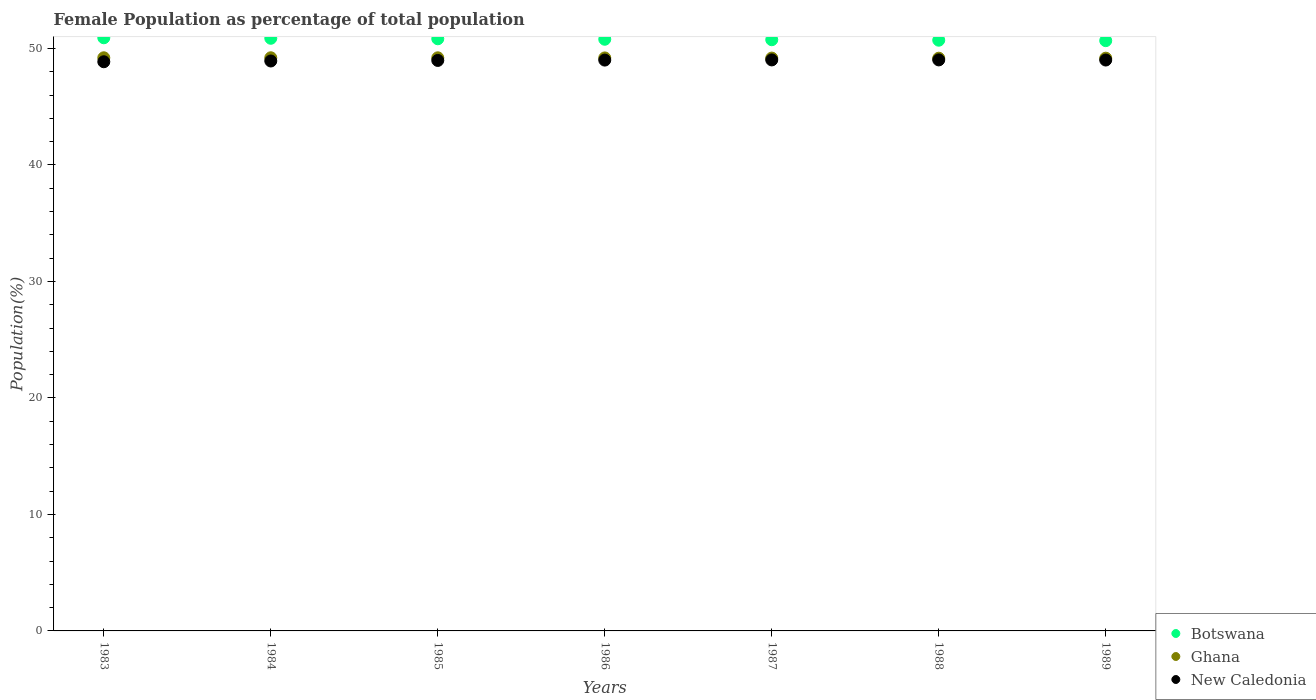What is the female population in in Botswana in 1984?
Ensure brevity in your answer.  50.87. Across all years, what is the maximum female population in in Botswana?
Ensure brevity in your answer.  50.91. Across all years, what is the minimum female population in in Ghana?
Ensure brevity in your answer.  49.16. In which year was the female population in in Botswana maximum?
Offer a very short reply. 1983. What is the total female population in in New Caledonia in the graph?
Give a very brief answer. 342.78. What is the difference between the female population in in New Caledonia in 1984 and that in 1989?
Keep it short and to the point. -0.08. What is the difference between the female population in in Ghana in 1983 and the female population in in Botswana in 1987?
Make the answer very short. -1.55. What is the average female population in in New Caledonia per year?
Your response must be concise. 48.97. In the year 1989, what is the difference between the female population in in Botswana and female population in in Ghana?
Provide a short and direct response. 1.51. What is the ratio of the female population in in New Caledonia in 1985 to that in 1986?
Offer a very short reply. 1. Is the difference between the female population in in Botswana in 1983 and 1988 greater than the difference between the female population in in Ghana in 1983 and 1988?
Your response must be concise. Yes. What is the difference between the highest and the second highest female population in in Botswana?
Your answer should be compact. 0.04. What is the difference between the highest and the lowest female population in in Botswana?
Provide a short and direct response. 0.25. In how many years, is the female population in in Botswana greater than the average female population in in Botswana taken over all years?
Offer a terse response. 3. Is it the case that in every year, the sum of the female population in in New Caledonia and female population in in Ghana  is greater than the female population in in Botswana?
Your answer should be compact. Yes. Is the female population in in Botswana strictly greater than the female population in in Ghana over the years?
Your response must be concise. Yes. Is the female population in in Botswana strictly less than the female population in in New Caledonia over the years?
Keep it short and to the point. No. How many years are there in the graph?
Give a very brief answer. 7. What is the difference between two consecutive major ticks on the Y-axis?
Your response must be concise. 10. Does the graph contain grids?
Offer a very short reply. No. How are the legend labels stacked?
Offer a very short reply. Vertical. What is the title of the graph?
Your answer should be compact. Female Population as percentage of total population. What is the label or title of the Y-axis?
Your response must be concise. Population(%). What is the Population(%) in Botswana in 1983?
Ensure brevity in your answer.  50.91. What is the Population(%) in Ghana in 1983?
Ensure brevity in your answer.  49.2. What is the Population(%) in New Caledonia in 1983?
Ensure brevity in your answer.  48.86. What is the Population(%) in Botswana in 1984?
Offer a terse response. 50.87. What is the Population(%) of Ghana in 1984?
Offer a very short reply. 49.2. What is the Population(%) of New Caledonia in 1984?
Your response must be concise. 48.92. What is the Population(%) of Botswana in 1985?
Your answer should be compact. 50.83. What is the Population(%) in Ghana in 1985?
Offer a very short reply. 49.2. What is the Population(%) in New Caledonia in 1985?
Offer a very short reply. 48.97. What is the Population(%) of Botswana in 1986?
Ensure brevity in your answer.  50.79. What is the Population(%) of Ghana in 1986?
Your response must be concise. 49.19. What is the Population(%) of New Caledonia in 1986?
Your answer should be compact. 49. What is the Population(%) of Botswana in 1987?
Your answer should be compact. 50.75. What is the Population(%) of Ghana in 1987?
Your answer should be very brief. 49.17. What is the Population(%) in New Caledonia in 1987?
Keep it short and to the point. 49.01. What is the Population(%) of Botswana in 1988?
Ensure brevity in your answer.  50.71. What is the Population(%) of Ghana in 1988?
Your answer should be compact. 49.16. What is the Population(%) of New Caledonia in 1988?
Your answer should be very brief. 49.01. What is the Population(%) of Botswana in 1989?
Your answer should be compact. 50.67. What is the Population(%) in Ghana in 1989?
Your answer should be very brief. 49.16. What is the Population(%) of New Caledonia in 1989?
Ensure brevity in your answer.  49. Across all years, what is the maximum Population(%) in Botswana?
Your answer should be compact. 50.91. Across all years, what is the maximum Population(%) of Ghana?
Ensure brevity in your answer.  49.2. Across all years, what is the maximum Population(%) of New Caledonia?
Ensure brevity in your answer.  49.01. Across all years, what is the minimum Population(%) in Botswana?
Give a very brief answer. 50.67. Across all years, what is the minimum Population(%) in Ghana?
Your answer should be compact. 49.16. Across all years, what is the minimum Population(%) in New Caledonia?
Your answer should be very brief. 48.86. What is the total Population(%) of Botswana in the graph?
Offer a very short reply. 355.53. What is the total Population(%) of Ghana in the graph?
Provide a succinct answer. 344.27. What is the total Population(%) of New Caledonia in the graph?
Provide a succinct answer. 342.78. What is the difference between the Population(%) of Botswana in 1983 and that in 1984?
Ensure brevity in your answer.  0.04. What is the difference between the Population(%) in Ghana in 1983 and that in 1984?
Ensure brevity in your answer.  -0. What is the difference between the Population(%) in New Caledonia in 1983 and that in 1984?
Your answer should be very brief. -0.07. What is the difference between the Population(%) in Botswana in 1983 and that in 1985?
Your response must be concise. 0.09. What is the difference between the Population(%) in Ghana in 1983 and that in 1985?
Your answer should be compact. 0. What is the difference between the Population(%) in New Caledonia in 1983 and that in 1985?
Your answer should be compact. -0.11. What is the difference between the Population(%) in Botswana in 1983 and that in 1986?
Make the answer very short. 0.13. What is the difference between the Population(%) of Ghana in 1983 and that in 1986?
Make the answer very short. 0.01. What is the difference between the Population(%) in New Caledonia in 1983 and that in 1986?
Offer a very short reply. -0.14. What is the difference between the Population(%) in Botswana in 1983 and that in 1987?
Offer a very short reply. 0.17. What is the difference between the Population(%) in Ghana in 1983 and that in 1987?
Ensure brevity in your answer.  0.03. What is the difference between the Population(%) of New Caledonia in 1983 and that in 1987?
Ensure brevity in your answer.  -0.16. What is the difference between the Population(%) of Botswana in 1983 and that in 1988?
Give a very brief answer. 0.21. What is the difference between the Population(%) of Ghana in 1983 and that in 1988?
Ensure brevity in your answer.  0.04. What is the difference between the Population(%) in New Caledonia in 1983 and that in 1988?
Offer a very short reply. -0.16. What is the difference between the Population(%) in Botswana in 1983 and that in 1989?
Offer a terse response. 0.25. What is the difference between the Population(%) of Ghana in 1983 and that in 1989?
Provide a succinct answer. 0.03. What is the difference between the Population(%) in New Caledonia in 1983 and that in 1989?
Give a very brief answer. -0.15. What is the difference between the Population(%) of Botswana in 1984 and that in 1985?
Keep it short and to the point. 0.04. What is the difference between the Population(%) in Ghana in 1984 and that in 1985?
Make the answer very short. 0. What is the difference between the Population(%) in New Caledonia in 1984 and that in 1985?
Make the answer very short. -0.05. What is the difference between the Population(%) in Botswana in 1984 and that in 1986?
Your answer should be very brief. 0.08. What is the difference between the Population(%) in Ghana in 1984 and that in 1986?
Offer a terse response. 0.01. What is the difference between the Population(%) in New Caledonia in 1984 and that in 1986?
Keep it short and to the point. -0.08. What is the difference between the Population(%) in Botswana in 1984 and that in 1987?
Ensure brevity in your answer.  0.12. What is the difference between the Population(%) in Ghana in 1984 and that in 1987?
Your response must be concise. 0.03. What is the difference between the Population(%) of New Caledonia in 1984 and that in 1987?
Ensure brevity in your answer.  -0.09. What is the difference between the Population(%) in Botswana in 1984 and that in 1988?
Provide a succinct answer. 0.16. What is the difference between the Population(%) in Ghana in 1984 and that in 1988?
Keep it short and to the point. 0.04. What is the difference between the Population(%) in New Caledonia in 1984 and that in 1988?
Your answer should be very brief. -0.09. What is the difference between the Population(%) of Botswana in 1984 and that in 1989?
Make the answer very short. 0.2. What is the difference between the Population(%) of Ghana in 1984 and that in 1989?
Your response must be concise. 0.04. What is the difference between the Population(%) in New Caledonia in 1984 and that in 1989?
Keep it short and to the point. -0.08. What is the difference between the Population(%) of Botswana in 1985 and that in 1986?
Offer a terse response. 0.04. What is the difference between the Population(%) of Ghana in 1985 and that in 1986?
Keep it short and to the point. 0.01. What is the difference between the Population(%) in New Caledonia in 1985 and that in 1986?
Your answer should be compact. -0.03. What is the difference between the Population(%) in Botswana in 1985 and that in 1987?
Provide a succinct answer. 0.08. What is the difference between the Population(%) in Ghana in 1985 and that in 1987?
Provide a succinct answer. 0.02. What is the difference between the Population(%) of New Caledonia in 1985 and that in 1987?
Give a very brief answer. -0.04. What is the difference between the Population(%) of Botswana in 1985 and that in 1988?
Offer a very short reply. 0.12. What is the difference between the Population(%) in Ghana in 1985 and that in 1988?
Your response must be concise. 0.04. What is the difference between the Population(%) of New Caledonia in 1985 and that in 1988?
Provide a succinct answer. -0.05. What is the difference between the Population(%) in Botswana in 1985 and that in 1989?
Provide a succinct answer. 0.16. What is the difference between the Population(%) in Ghana in 1985 and that in 1989?
Offer a very short reply. 0.03. What is the difference between the Population(%) of New Caledonia in 1985 and that in 1989?
Make the answer very short. -0.03. What is the difference between the Population(%) in Botswana in 1986 and that in 1987?
Your answer should be compact. 0.04. What is the difference between the Population(%) of Ghana in 1986 and that in 1987?
Offer a very short reply. 0.01. What is the difference between the Population(%) of New Caledonia in 1986 and that in 1987?
Your answer should be very brief. -0.01. What is the difference between the Population(%) of Botswana in 1986 and that in 1988?
Offer a terse response. 0.08. What is the difference between the Population(%) in Ghana in 1986 and that in 1988?
Make the answer very short. 0.03. What is the difference between the Population(%) in New Caledonia in 1986 and that in 1988?
Make the answer very short. -0.02. What is the difference between the Population(%) of Botswana in 1986 and that in 1989?
Make the answer very short. 0.12. What is the difference between the Population(%) of Ghana in 1986 and that in 1989?
Your answer should be compact. 0.02. What is the difference between the Population(%) of New Caledonia in 1986 and that in 1989?
Offer a very short reply. -0. What is the difference between the Population(%) in Ghana in 1987 and that in 1988?
Make the answer very short. 0.01. What is the difference between the Population(%) of New Caledonia in 1987 and that in 1988?
Offer a very short reply. -0. What is the difference between the Population(%) in Botswana in 1987 and that in 1989?
Provide a succinct answer. 0.08. What is the difference between the Population(%) of Ghana in 1987 and that in 1989?
Ensure brevity in your answer.  0.01. What is the difference between the Population(%) in New Caledonia in 1987 and that in 1989?
Your response must be concise. 0.01. What is the difference between the Population(%) of Botswana in 1988 and that in 1989?
Keep it short and to the point. 0.04. What is the difference between the Population(%) in Ghana in 1988 and that in 1989?
Provide a short and direct response. -0. What is the difference between the Population(%) in New Caledonia in 1988 and that in 1989?
Make the answer very short. 0.01. What is the difference between the Population(%) in Botswana in 1983 and the Population(%) in Ghana in 1984?
Your answer should be compact. 1.72. What is the difference between the Population(%) of Botswana in 1983 and the Population(%) of New Caledonia in 1984?
Offer a very short reply. 1.99. What is the difference between the Population(%) of Ghana in 1983 and the Population(%) of New Caledonia in 1984?
Make the answer very short. 0.28. What is the difference between the Population(%) of Botswana in 1983 and the Population(%) of Ghana in 1985?
Your answer should be compact. 1.72. What is the difference between the Population(%) in Botswana in 1983 and the Population(%) in New Caledonia in 1985?
Keep it short and to the point. 1.95. What is the difference between the Population(%) of Ghana in 1983 and the Population(%) of New Caledonia in 1985?
Give a very brief answer. 0.23. What is the difference between the Population(%) of Botswana in 1983 and the Population(%) of Ghana in 1986?
Keep it short and to the point. 1.73. What is the difference between the Population(%) in Botswana in 1983 and the Population(%) in New Caledonia in 1986?
Your response must be concise. 1.92. What is the difference between the Population(%) in Ghana in 1983 and the Population(%) in New Caledonia in 1986?
Provide a short and direct response. 0.2. What is the difference between the Population(%) of Botswana in 1983 and the Population(%) of Ghana in 1987?
Offer a very short reply. 1.74. What is the difference between the Population(%) in Botswana in 1983 and the Population(%) in New Caledonia in 1987?
Your answer should be compact. 1.9. What is the difference between the Population(%) in Ghana in 1983 and the Population(%) in New Caledonia in 1987?
Offer a very short reply. 0.18. What is the difference between the Population(%) in Botswana in 1983 and the Population(%) in Ghana in 1988?
Make the answer very short. 1.75. What is the difference between the Population(%) of Botswana in 1983 and the Population(%) of New Caledonia in 1988?
Keep it short and to the point. 1.9. What is the difference between the Population(%) in Ghana in 1983 and the Population(%) in New Caledonia in 1988?
Your answer should be very brief. 0.18. What is the difference between the Population(%) in Botswana in 1983 and the Population(%) in Ghana in 1989?
Offer a very short reply. 1.75. What is the difference between the Population(%) of Botswana in 1983 and the Population(%) of New Caledonia in 1989?
Offer a terse response. 1.91. What is the difference between the Population(%) in Ghana in 1983 and the Population(%) in New Caledonia in 1989?
Provide a short and direct response. 0.19. What is the difference between the Population(%) in Botswana in 1984 and the Population(%) in Ghana in 1985?
Ensure brevity in your answer.  1.68. What is the difference between the Population(%) in Botswana in 1984 and the Population(%) in New Caledonia in 1985?
Your answer should be compact. 1.9. What is the difference between the Population(%) in Ghana in 1984 and the Population(%) in New Caledonia in 1985?
Your response must be concise. 0.23. What is the difference between the Population(%) in Botswana in 1984 and the Population(%) in Ghana in 1986?
Keep it short and to the point. 1.69. What is the difference between the Population(%) in Botswana in 1984 and the Population(%) in New Caledonia in 1986?
Your answer should be very brief. 1.87. What is the difference between the Population(%) in Ghana in 1984 and the Population(%) in New Caledonia in 1986?
Give a very brief answer. 0.2. What is the difference between the Population(%) in Botswana in 1984 and the Population(%) in Ghana in 1987?
Make the answer very short. 1.7. What is the difference between the Population(%) in Botswana in 1984 and the Population(%) in New Caledonia in 1987?
Your response must be concise. 1.86. What is the difference between the Population(%) of Ghana in 1984 and the Population(%) of New Caledonia in 1987?
Give a very brief answer. 0.18. What is the difference between the Population(%) in Botswana in 1984 and the Population(%) in Ghana in 1988?
Provide a succinct answer. 1.71. What is the difference between the Population(%) of Botswana in 1984 and the Population(%) of New Caledonia in 1988?
Provide a short and direct response. 1.86. What is the difference between the Population(%) in Ghana in 1984 and the Population(%) in New Caledonia in 1988?
Your answer should be very brief. 0.18. What is the difference between the Population(%) in Botswana in 1984 and the Population(%) in Ghana in 1989?
Offer a terse response. 1.71. What is the difference between the Population(%) in Botswana in 1984 and the Population(%) in New Caledonia in 1989?
Your answer should be very brief. 1.87. What is the difference between the Population(%) in Ghana in 1984 and the Population(%) in New Caledonia in 1989?
Ensure brevity in your answer.  0.19. What is the difference between the Population(%) of Botswana in 1985 and the Population(%) of Ghana in 1986?
Provide a succinct answer. 1.64. What is the difference between the Population(%) in Botswana in 1985 and the Population(%) in New Caledonia in 1986?
Keep it short and to the point. 1.83. What is the difference between the Population(%) of Ghana in 1985 and the Population(%) of New Caledonia in 1986?
Your answer should be very brief. 0.2. What is the difference between the Population(%) of Botswana in 1985 and the Population(%) of Ghana in 1987?
Your answer should be compact. 1.66. What is the difference between the Population(%) in Botswana in 1985 and the Population(%) in New Caledonia in 1987?
Your answer should be very brief. 1.81. What is the difference between the Population(%) of Ghana in 1985 and the Population(%) of New Caledonia in 1987?
Make the answer very short. 0.18. What is the difference between the Population(%) in Botswana in 1985 and the Population(%) in Ghana in 1988?
Keep it short and to the point. 1.67. What is the difference between the Population(%) of Botswana in 1985 and the Population(%) of New Caledonia in 1988?
Keep it short and to the point. 1.81. What is the difference between the Population(%) of Ghana in 1985 and the Population(%) of New Caledonia in 1988?
Offer a very short reply. 0.18. What is the difference between the Population(%) in Botswana in 1985 and the Population(%) in Ghana in 1989?
Offer a very short reply. 1.67. What is the difference between the Population(%) in Botswana in 1985 and the Population(%) in New Caledonia in 1989?
Ensure brevity in your answer.  1.83. What is the difference between the Population(%) in Ghana in 1985 and the Population(%) in New Caledonia in 1989?
Ensure brevity in your answer.  0.19. What is the difference between the Population(%) of Botswana in 1986 and the Population(%) of Ghana in 1987?
Give a very brief answer. 1.62. What is the difference between the Population(%) of Botswana in 1986 and the Population(%) of New Caledonia in 1987?
Keep it short and to the point. 1.77. What is the difference between the Population(%) of Ghana in 1986 and the Population(%) of New Caledonia in 1987?
Your answer should be very brief. 0.17. What is the difference between the Population(%) in Botswana in 1986 and the Population(%) in Ghana in 1988?
Your answer should be compact. 1.63. What is the difference between the Population(%) in Botswana in 1986 and the Population(%) in New Caledonia in 1988?
Your answer should be very brief. 1.77. What is the difference between the Population(%) in Ghana in 1986 and the Population(%) in New Caledonia in 1988?
Give a very brief answer. 0.17. What is the difference between the Population(%) in Botswana in 1986 and the Population(%) in Ghana in 1989?
Offer a terse response. 1.63. What is the difference between the Population(%) in Botswana in 1986 and the Population(%) in New Caledonia in 1989?
Your response must be concise. 1.78. What is the difference between the Population(%) of Ghana in 1986 and the Population(%) of New Caledonia in 1989?
Give a very brief answer. 0.18. What is the difference between the Population(%) in Botswana in 1987 and the Population(%) in Ghana in 1988?
Give a very brief answer. 1.59. What is the difference between the Population(%) of Botswana in 1987 and the Population(%) of New Caledonia in 1988?
Your response must be concise. 1.73. What is the difference between the Population(%) of Ghana in 1987 and the Population(%) of New Caledonia in 1988?
Your response must be concise. 0.16. What is the difference between the Population(%) in Botswana in 1987 and the Population(%) in Ghana in 1989?
Your answer should be very brief. 1.58. What is the difference between the Population(%) of Botswana in 1987 and the Population(%) of New Caledonia in 1989?
Keep it short and to the point. 1.74. What is the difference between the Population(%) in Ghana in 1987 and the Population(%) in New Caledonia in 1989?
Offer a terse response. 0.17. What is the difference between the Population(%) of Botswana in 1988 and the Population(%) of Ghana in 1989?
Your answer should be compact. 1.54. What is the difference between the Population(%) in Botswana in 1988 and the Population(%) in New Caledonia in 1989?
Your response must be concise. 1.7. What is the difference between the Population(%) in Ghana in 1988 and the Population(%) in New Caledonia in 1989?
Ensure brevity in your answer.  0.16. What is the average Population(%) of Botswana per year?
Your response must be concise. 50.79. What is the average Population(%) of Ghana per year?
Offer a very short reply. 49.18. What is the average Population(%) in New Caledonia per year?
Ensure brevity in your answer.  48.97. In the year 1983, what is the difference between the Population(%) in Botswana and Population(%) in Ghana?
Provide a short and direct response. 1.72. In the year 1983, what is the difference between the Population(%) in Botswana and Population(%) in New Caledonia?
Offer a very short reply. 2.06. In the year 1983, what is the difference between the Population(%) of Ghana and Population(%) of New Caledonia?
Keep it short and to the point. 0.34. In the year 1984, what is the difference between the Population(%) of Botswana and Population(%) of Ghana?
Offer a terse response. 1.67. In the year 1984, what is the difference between the Population(%) of Botswana and Population(%) of New Caledonia?
Provide a succinct answer. 1.95. In the year 1984, what is the difference between the Population(%) of Ghana and Population(%) of New Caledonia?
Offer a very short reply. 0.28. In the year 1985, what is the difference between the Population(%) of Botswana and Population(%) of Ghana?
Offer a terse response. 1.63. In the year 1985, what is the difference between the Population(%) of Botswana and Population(%) of New Caledonia?
Ensure brevity in your answer.  1.86. In the year 1985, what is the difference between the Population(%) in Ghana and Population(%) in New Caledonia?
Provide a succinct answer. 0.23. In the year 1986, what is the difference between the Population(%) of Botswana and Population(%) of Ghana?
Ensure brevity in your answer.  1.6. In the year 1986, what is the difference between the Population(%) in Botswana and Population(%) in New Caledonia?
Offer a very short reply. 1.79. In the year 1986, what is the difference between the Population(%) of Ghana and Population(%) of New Caledonia?
Offer a terse response. 0.19. In the year 1987, what is the difference between the Population(%) in Botswana and Population(%) in Ghana?
Provide a succinct answer. 1.58. In the year 1987, what is the difference between the Population(%) of Botswana and Population(%) of New Caledonia?
Provide a short and direct response. 1.73. In the year 1987, what is the difference between the Population(%) in Ghana and Population(%) in New Caledonia?
Keep it short and to the point. 0.16. In the year 1988, what is the difference between the Population(%) of Botswana and Population(%) of Ghana?
Provide a short and direct response. 1.55. In the year 1988, what is the difference between the Population(%) of Botswana and Population(%) of New Caledonia?
Provide a short and direct response. 1.69. In the year 1988, what is the difference between the Population(%) of Ghana and Population(%) of New Caledonia?
Provide a short and direct response. 0.15. In the year 1989, what is the difference between the Population(%) in Botswana and Population(%) in Ghana?
Keep it short and to the point. 1.51. In the year 1989, what is the difference between the Population(%) in Botswana and Population(%) in New Caledonia?
Make the answer very short. 1.66. In the year 1989, what is the difference between the Population(%) of Ghana and Population(%) of New Caledonia?
Provide a succinct answer. 0.16. What is the ratio of the Population(%) of New Caledonia in 1983 to that in 1984?
Your answer should be compact. 1. What is the ratio of the Population(%) in New Caledonia in 1983 to that in 1985?
Provide a succinct answer. 1. What is the ratio of the Population(%) in Ghana in 1983 to that in 1986?
Your answer should be very brief. 1. What is the ratio of the Population(%) in Botswana in 1983 to that in 1987?
Provide a succinct answer. 1. What is the ratio of the Population(%) of Ghana in 1983 to that in 1988?
Offer a very short reply. 1. What is the ratio of the Population(%) of New Caledonia in 1983 to that in 1988?
Provide a short and direct response. 1. What is the ratio of the Population(%) in Ghana in 1983 to that in 1989?
Give a very brief answer. 1. What is the ratio of the Population(%) of Botswana in 1984 to that in 1985?
Offer a very short reply. 1. What is the ratio of the Population(%) of New Caledonia in 1984 to that in 1985?
Make the answer very short. 1. What is the ratio of the Population(%) of Ghana in 1984 to that in 1986?
Your answer should be compact. 1. What is the ratio of the Population(%) in New Caledonia in 1984 to that in 1986?
Offer a very short reply. 1. What is the ratio of the Population(%) in Ghana in 1984 to that in 1987?
Your response must be concise. 1. What is the ratio of the Population(%) of Ghana in 1984 to that in 1988?
Provide a succinct answer. 1. What is the ratio of the Population(%) in Botswana in 1984 to that in 1989?
Give a very brief answer. 1. What is the ratio of the Population(%) of Ghana in 1984 to that in 1989?
Provide a succinct answer. 1. What is the ratio of the Population(%) in Ghana in 1985 to that in 1986?
Provide a succinct answer. 1. What is the ratio of the Population(%) in New Caledonia in 1985 to that in 1986?
Make the answer very short. 1. What is the ratio of the Population(%) in Botswana in 1985 to that in 1987?
Provide a succinct answer. 1. What is the ratio of the Population(%) in New Caledonia in 1985 to that in 1987?
Provide a succinct answer. 1. What is the ratio of the Population(%) in Botswana in 1985 to that in 1988?
Give a very brief answer. 1. What is the ratio of the Population(%) in Ghana in 1985 to that in 1988?
Give a very brief answer. 1. What is the ratio of the Population(%) in Botswana in 1985 to that in 1989?
Offer a terse response. 1. What is the ratio of the Population(%) of Ghana in 1985 to that in 1989?
Your answer should be compact. 1. What is the ratio of the Population(%) of New Caledonia in 1985 to that in 1989?
Keep it short and to the point. 1. What is the ratio of the Population(%) in Botswana in 1986 to that in 1987?
Give a very brief answer. 1. What is the ratio of the Population(%) of Ghana in 1986 to that in 1988?
Provide a short and direct response. 1. What is the ratio of the Population(%) of Botswana in 1986 to that in 1989?
Offer a terse response. 1. What is the ratio of the Population(%) of Ghana in 1987 to that in 1988?
Ensure brevity in your answer.  1. What is the ratio of the Population(%) in New Caledonia in 1987 to that in 1988?
Ensure brevity in your answer.  1. What is the ratio of the Population(%) in Botswana in 1987 to that in 1989?
Keep it short and to the point. 1. What is the ratio of the Population(%) in Ghana in 1987 to that in 1989?
Keep it short and to the point. 1. What is the difference between the highest and the second highest Population(%) in Botswana?
Your response must be concise. 0.04. What is the difference between the highest and the second highest Population(%) of Ghana?
Ensure brevity in your answer.  0. What is the difference between the highest and the second highest Population(%) of New Caledonia?
Make the answer very short. 0. What is the difference between the highest and the lowest Population(%) in Botswana?
Make the answer very short. 0.25. What is the difference between the highest and the lowest Population(%) in Ghana?
Provide a succinct answer. 0.04. What is the difference between the highest and the lowest Population(%) of New Caledonia?
Make the answer very short. 0.16. 